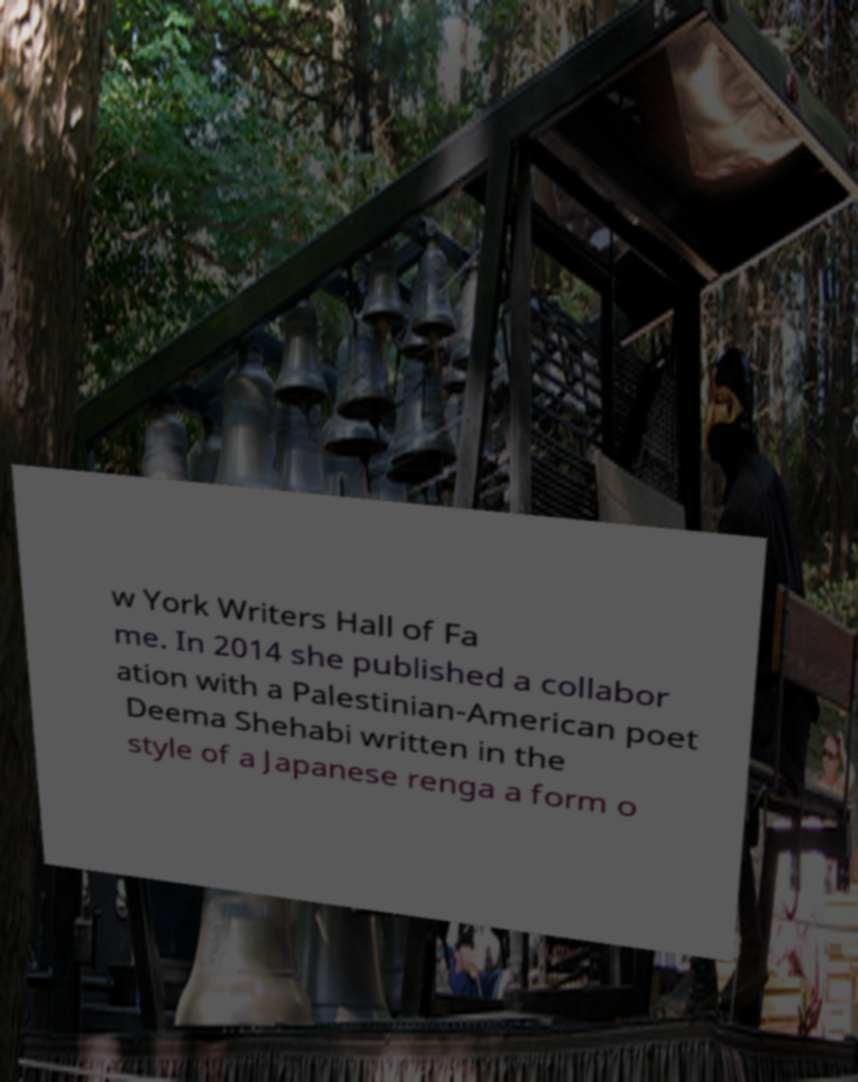What messages or text are displayed in this image? I need them in a readable, typed format. w York Writers Hall of Fa me. In 2014 she published a collabor ation with a Palestinian-American poet Deema Shehabi written in the style of a Japanese renga a form o 